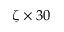<formula> <loc_0><loc_0><loc_500><loc_500>\zeta \times 3 0</formula> 